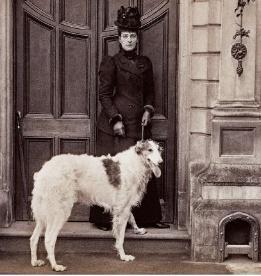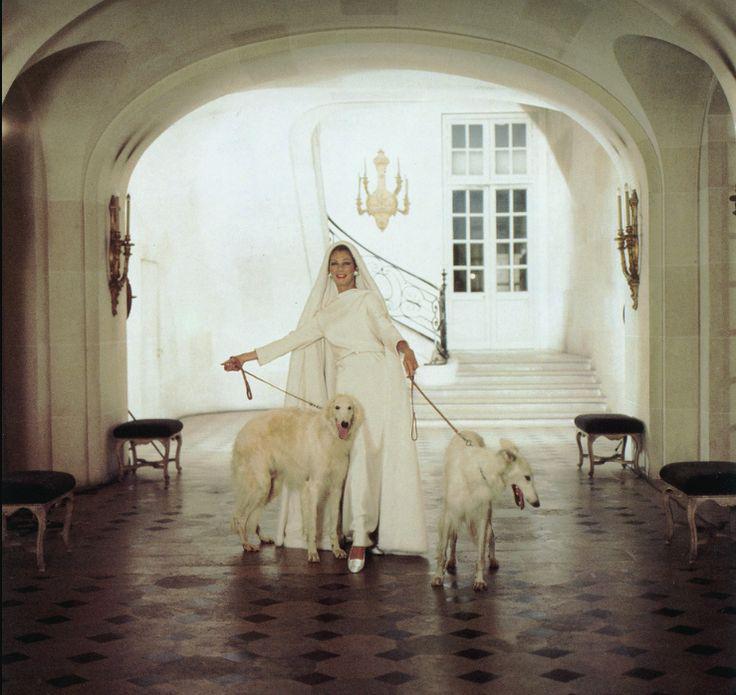The first image is the image on the left, the second image is the image on the right. Examine the images to the left and right. Is the description "There are three dogs in the image pair." accurate? Answer yes or no. Yes. The first image is the image on the left, the second image is the image on the right. Examine the images to the left and right. Is the description "A lady wearing a long dress is with her dogs in at least one of the images." accurate? Answer yes or no. Yes. 